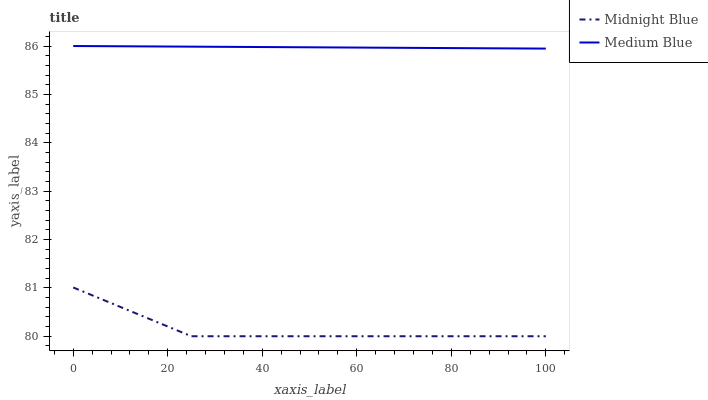Does Midnight Blue have the minimum area under the curve?
Answer yes or no. Yes. Does Medium Blue have the maximum area under the curve?
Answer yes or no. Yes. Does Midnight Blue have the maximum area under the curve?
Answer yes or no. No. Is Medium Blue the smoothest?
Answer yes or no. Yes. Is Midnight Blue the roughest?
Answer yes or no. Yes. Is Midnight Blue the smoothest?
Answer yes or no. No. Does Midnight Blue have the lowest value?
Answer yes or no. Yes. Does Medium Blue have the highest value?
Answer yes or no. Yes. Does Midnight Blue have the highest value?
Answer yes or no. No. Is Midnight Blue less than Medium Blue?
Answer yes or no. Yes. Is Medium Blue greater than Midnight Blue?
Answer yes or no. Yes. Does Midnight Blue intersect Medium Blue?
Answer yes or no. No. 